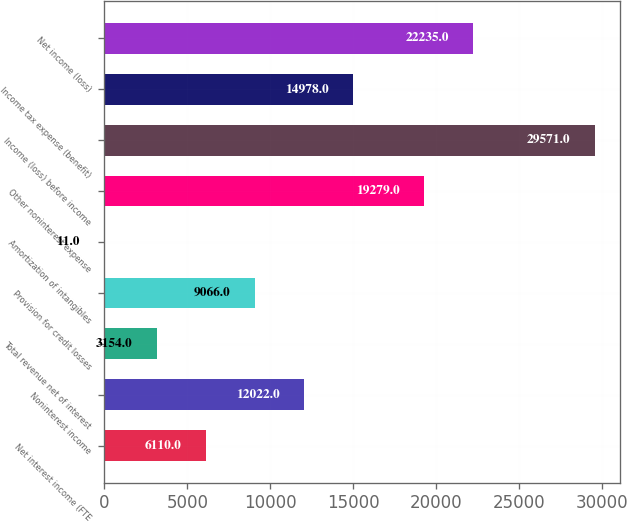Convert chart. <chart><loc_0><loc_0><loc_500><loc_500><bar_chart><fcel>Net interest income (FTE<fcel>Noninterest income<fcel>Total revenue net of interest<fcel>Provision for credit losses<fcel>Amortization of intangibles<fcel>Other noninterest expense<fcel>Income (loss) before income<fcel>Income tax expense (benefit)<fcel>Net income (loss)<nl><fcel>6110<fcel>12022<fcel>3154<fcel>9066<fcel>11<fcel>19279<fcel>29571<fcel>14978<fcel>22235<nl></chart> 